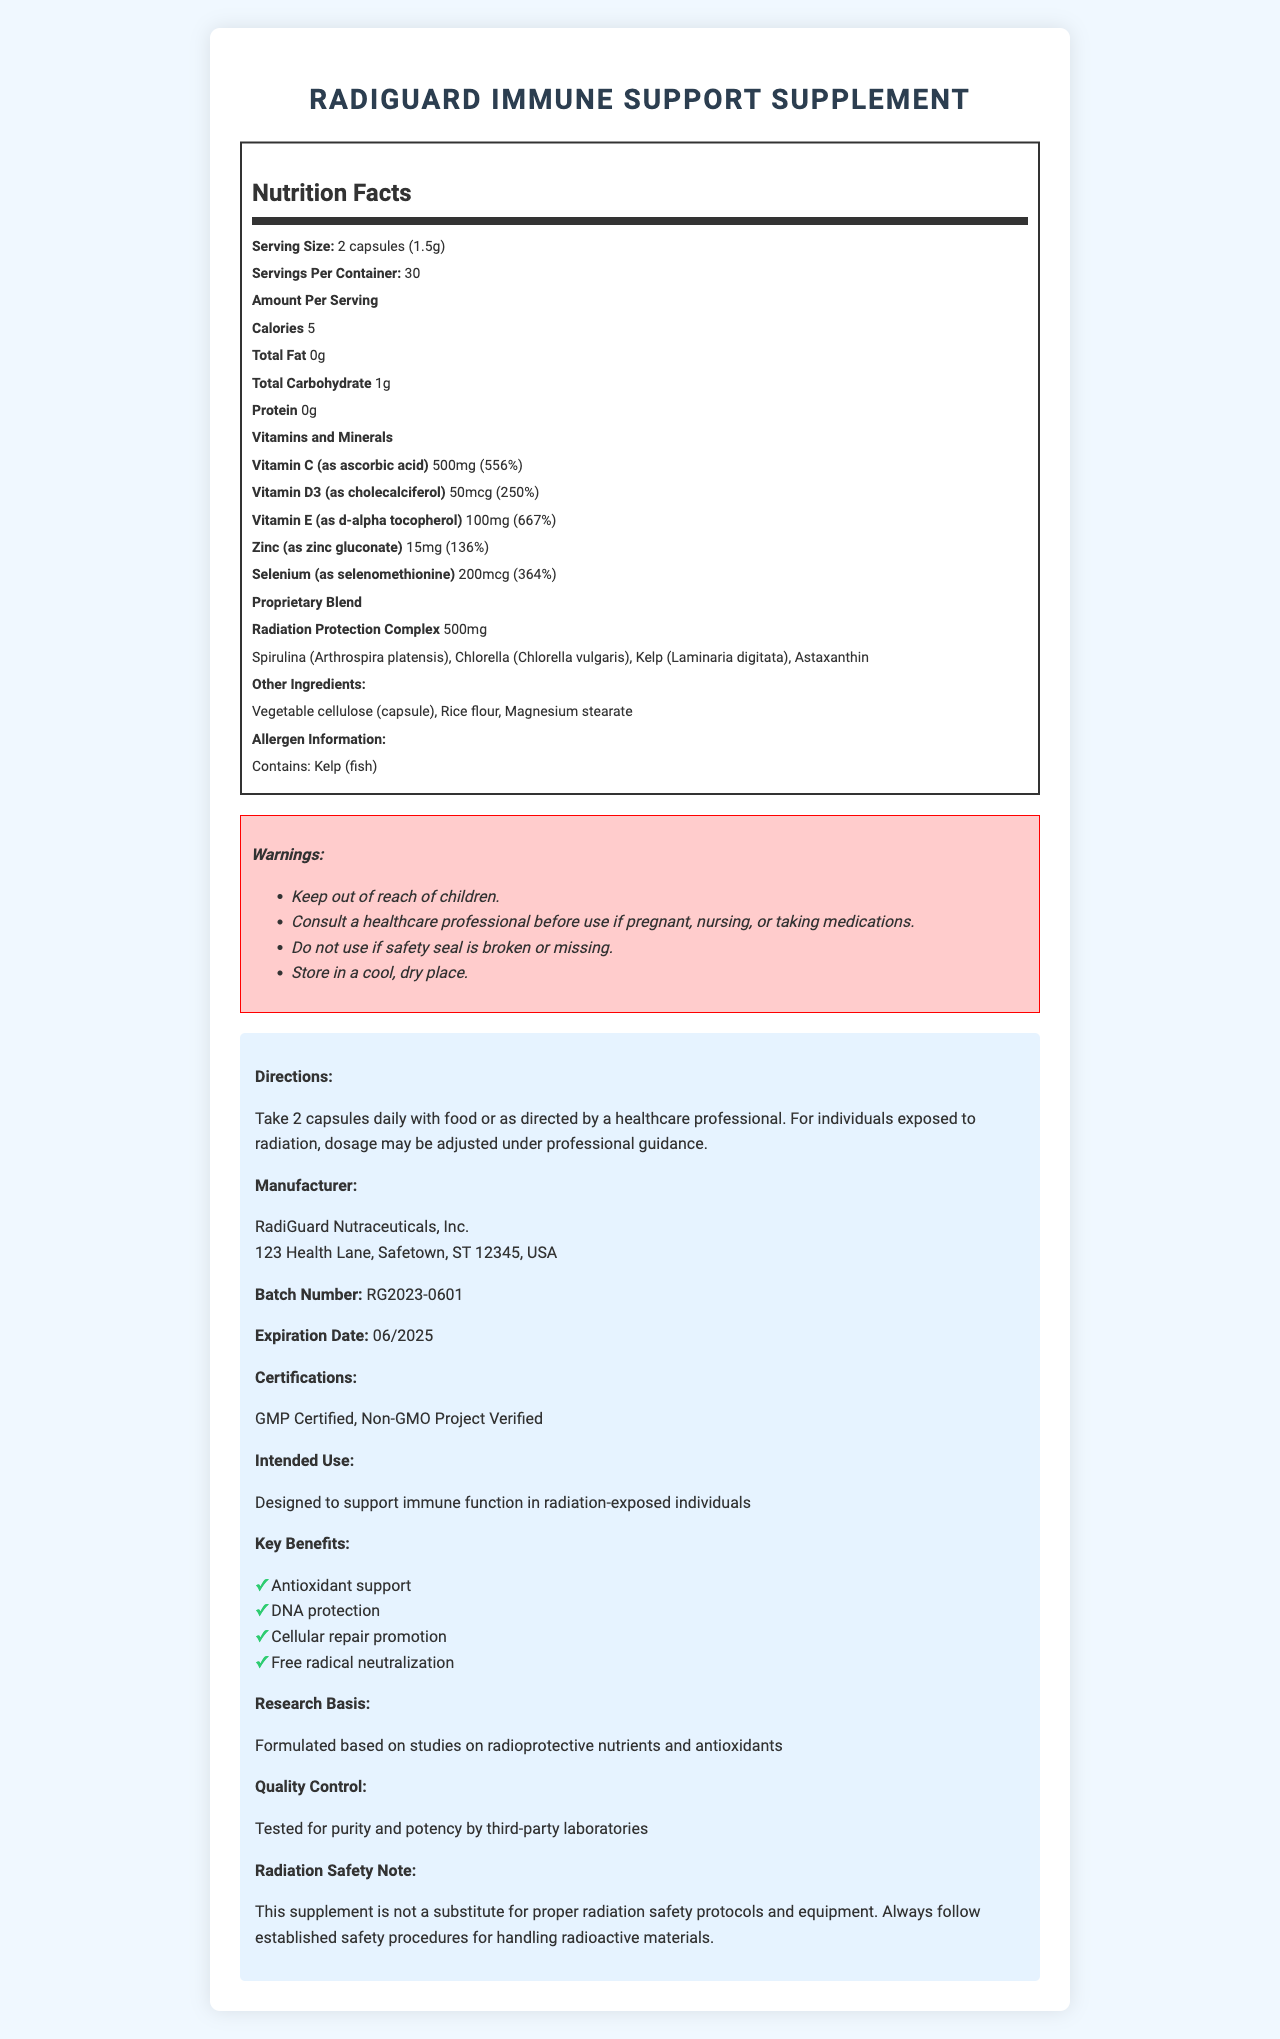Which vitamins and minerals are included in RadiGuard Immune Support Supplement? The document lists Vitamin C, Vitamin D3, Vitamin E, Zinc, and Selenium under the "Vitamins and Minerals" section.
Answer: Vitamin C, Vitamin D3, Vitamin E, Zinc, Selenium What is the serving size for RadiGuard Immune Support Supplement? The serving size is mentioned at the top of the nutrition label as "2 capsules (1.5g)".
Answer: 2 capsules (1.5g) How many servings are there per container of RadiGuard Immune Support Supplement? The document states "Servings Per Container: 30" which indicates there are 30 servings per container.
Answer: 30 What is the daily value percentage of Vitamin C in RadiGuard Immune Support Supplement? Under the "Vitamins and Minerals" section, it lists Vitamin C as having 556% of the daily value.
Answer: 556% List the ingredients in the Radiation Protection Complex. These ingredients are listed under the "Radiation Protection Complex" in the proprietary blend section.
Answer: Spirulina, Chlorella, Kelp, Astaxanthin Is the supplement free of any fats? The document shows "Total Fat: 0g," indicating there is no fat in the supplement.
Answer: Yes What is one of the warnings mentioned in the document? The document lists several warnings, one of which is "Keep out of reach of children."
Answer: "Keep out of reach of children." Which certifications does the RadiGuard Immune Support Supplement have? A. USDA Organic B. GMP Certified C. Non-GMO Project Verified D. Both B and C The document states that the supplement is "GMP Certified" and "Non-GMO Project Verified."
Answer: D. Both B and C How much Zinc is in each serving of RadiGuard Immune Support Supplement? A. 5mg B. 10mg C. 15mg D. 20mg The document lists Zinc as 15mg per serving in the "Vitamins and Minerals" section.
Answer: C. 15mg Does the RadiGuard Immune Support Supplement contain any allergens? The document specifies "Contains: Kelp (fish)" under the allergen information.
Answer: Yes Summarize the main purpose of the RadiGuard Immune Support Supplement. The document indicates that the supplement is "Designed to support immune function in radiation-exposed individuals" and lists related benefits such as antioxidant support and cellular repair promotion.
Answer: To support immune function in radiation-exposed individuals What is the primary caution regarding this supplement for individuals who handle radioactive materials? Under the "Radiation Safety Note," the document emphasizes the importance of following established safety procedures for handling radioactive materials.
Answer: This supplement is not a substitute for proper radiation safety protocols and equipment. What is the expiration date of this specific batch of the supplement? The expiration date is listed near the end of the document as "Expiration Date: 06/2025."
Answer: 06/2025 What are the manufacturer details of the RadiGuard Immune Support Supplement? The manufacturer's name and address are provided under the "Manufacturer" section.
Answer: RadiGuard Nutraceuticals, Inc., 123 Health Lane, Safetown, ST 12345, USA How much of the proprietary blend is in each serving? The document lists the "Radiation Protection Complex" proprietary blend as 500mg.
Answer: 500mg How many calories are in each serving of RadiGuard Immune Support Supplement? The document lists the calories per serving as 5 in the nutrition facts section.
Answer: 5 